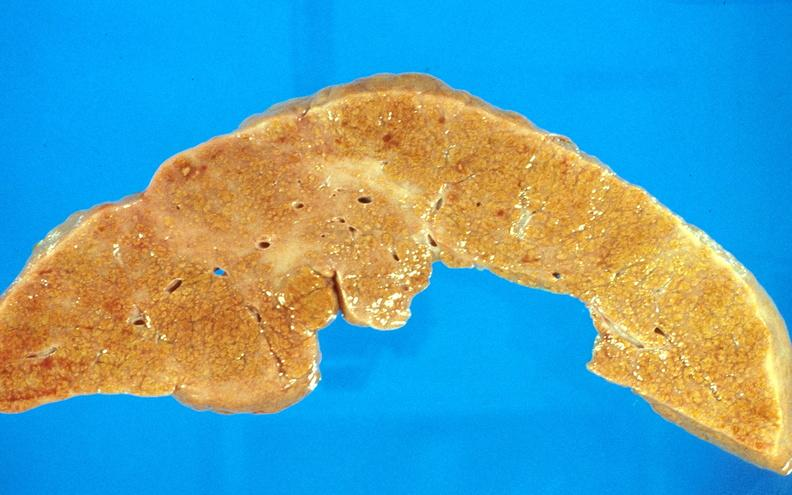what is present?
Answer the question using a single word or phrase. Hepatobiliary 